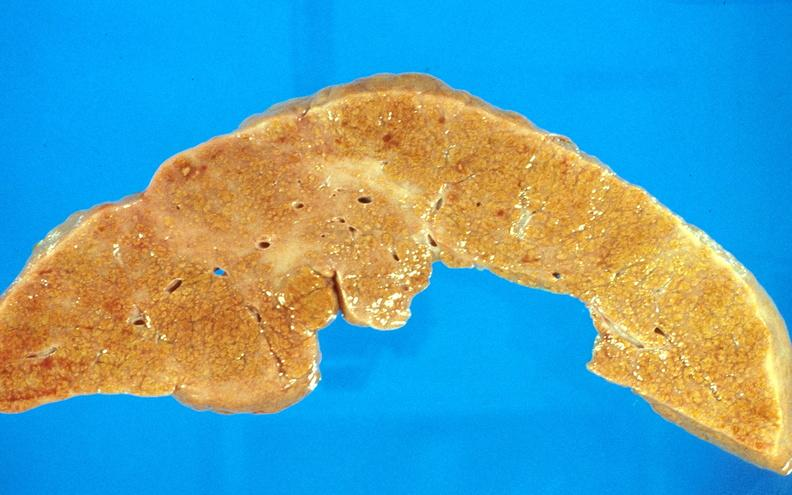what is present?
Answer the question using a single word or phrase. Hepatobiliary 